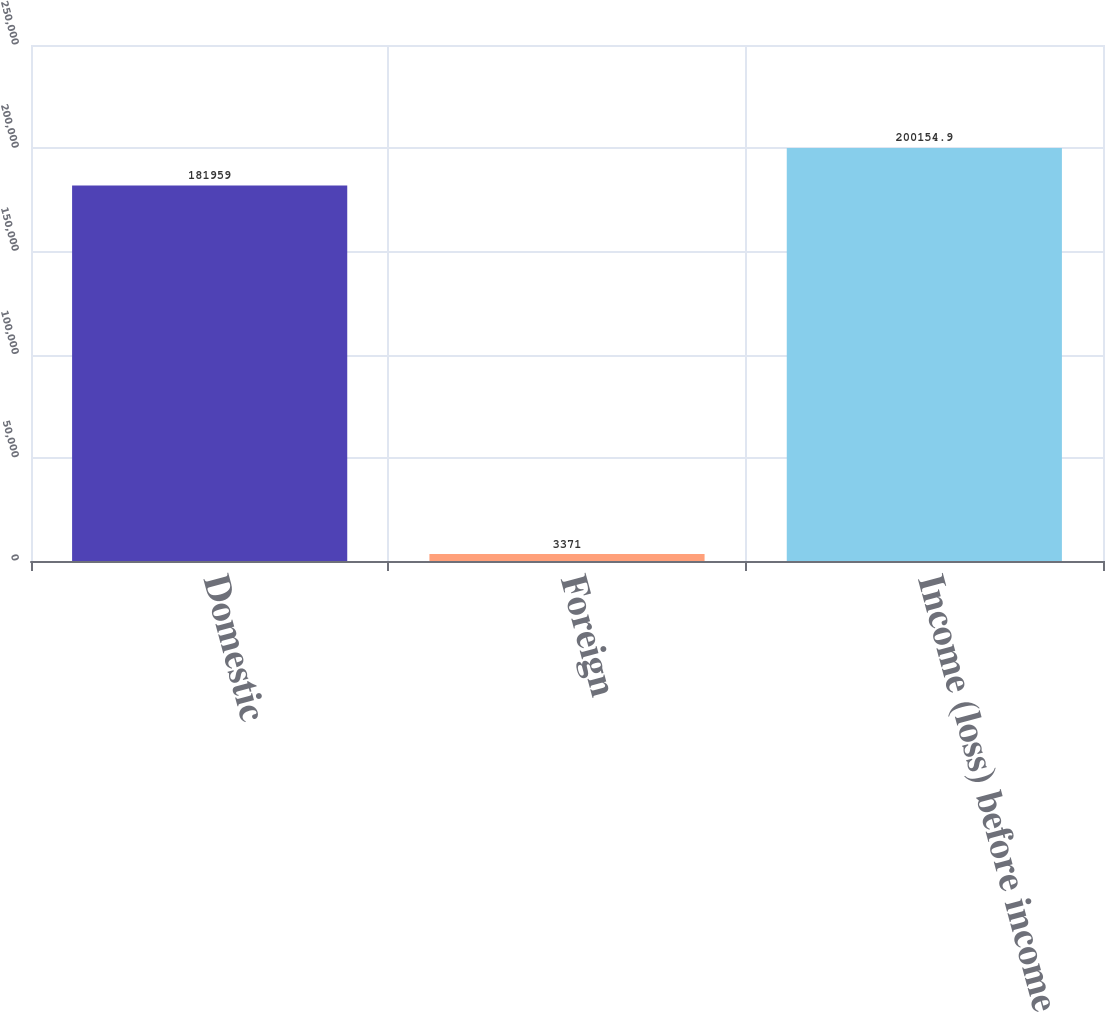<chart> <loc_0><loc_0><loc_500><loc_500><bar_chart><fcel>Domestic<fcel>Foreign<fcel>Income (loss) before income<nl><fcel>181959<fcel>3371<fcel>200155<nl></chart> 